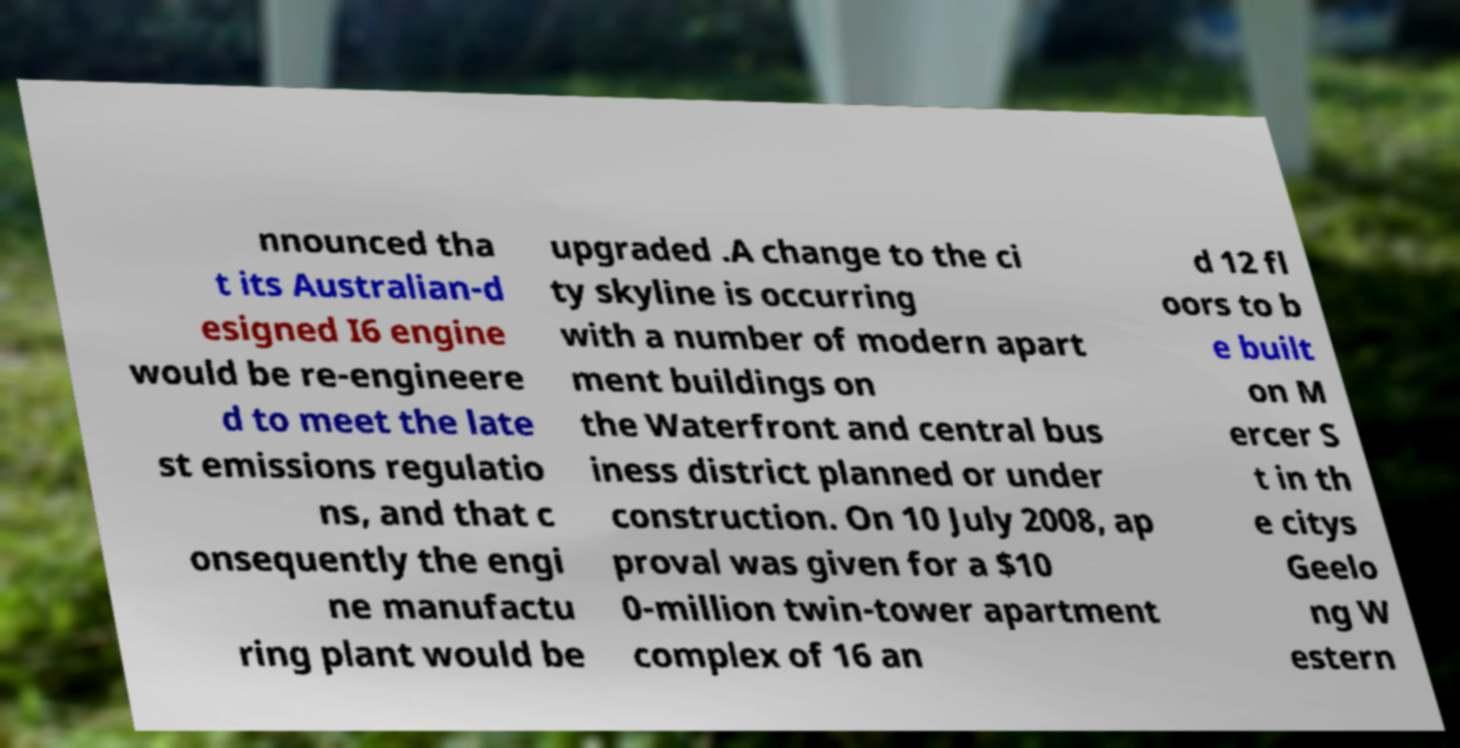I need the written content from this picture converted into text. Can you do that? nnounced tha t its Australian-d esigned I6 engine would be re-engineere d to meet the late st emissions regulatio ns, and that c onsequently the engi ne manufactu ring plant would be upgraded .A change to the ci ty skyline is occurring with a number of modern apart ment buildings on the Waterfront and central bus iness district planned or under construction. On 10 July 2008, ap proval was given for a $10 0-million twin-tower apartment complex of 16 an d 12 fl oors to b e built on M ercer S t in th e citys Geelo ng W estern 